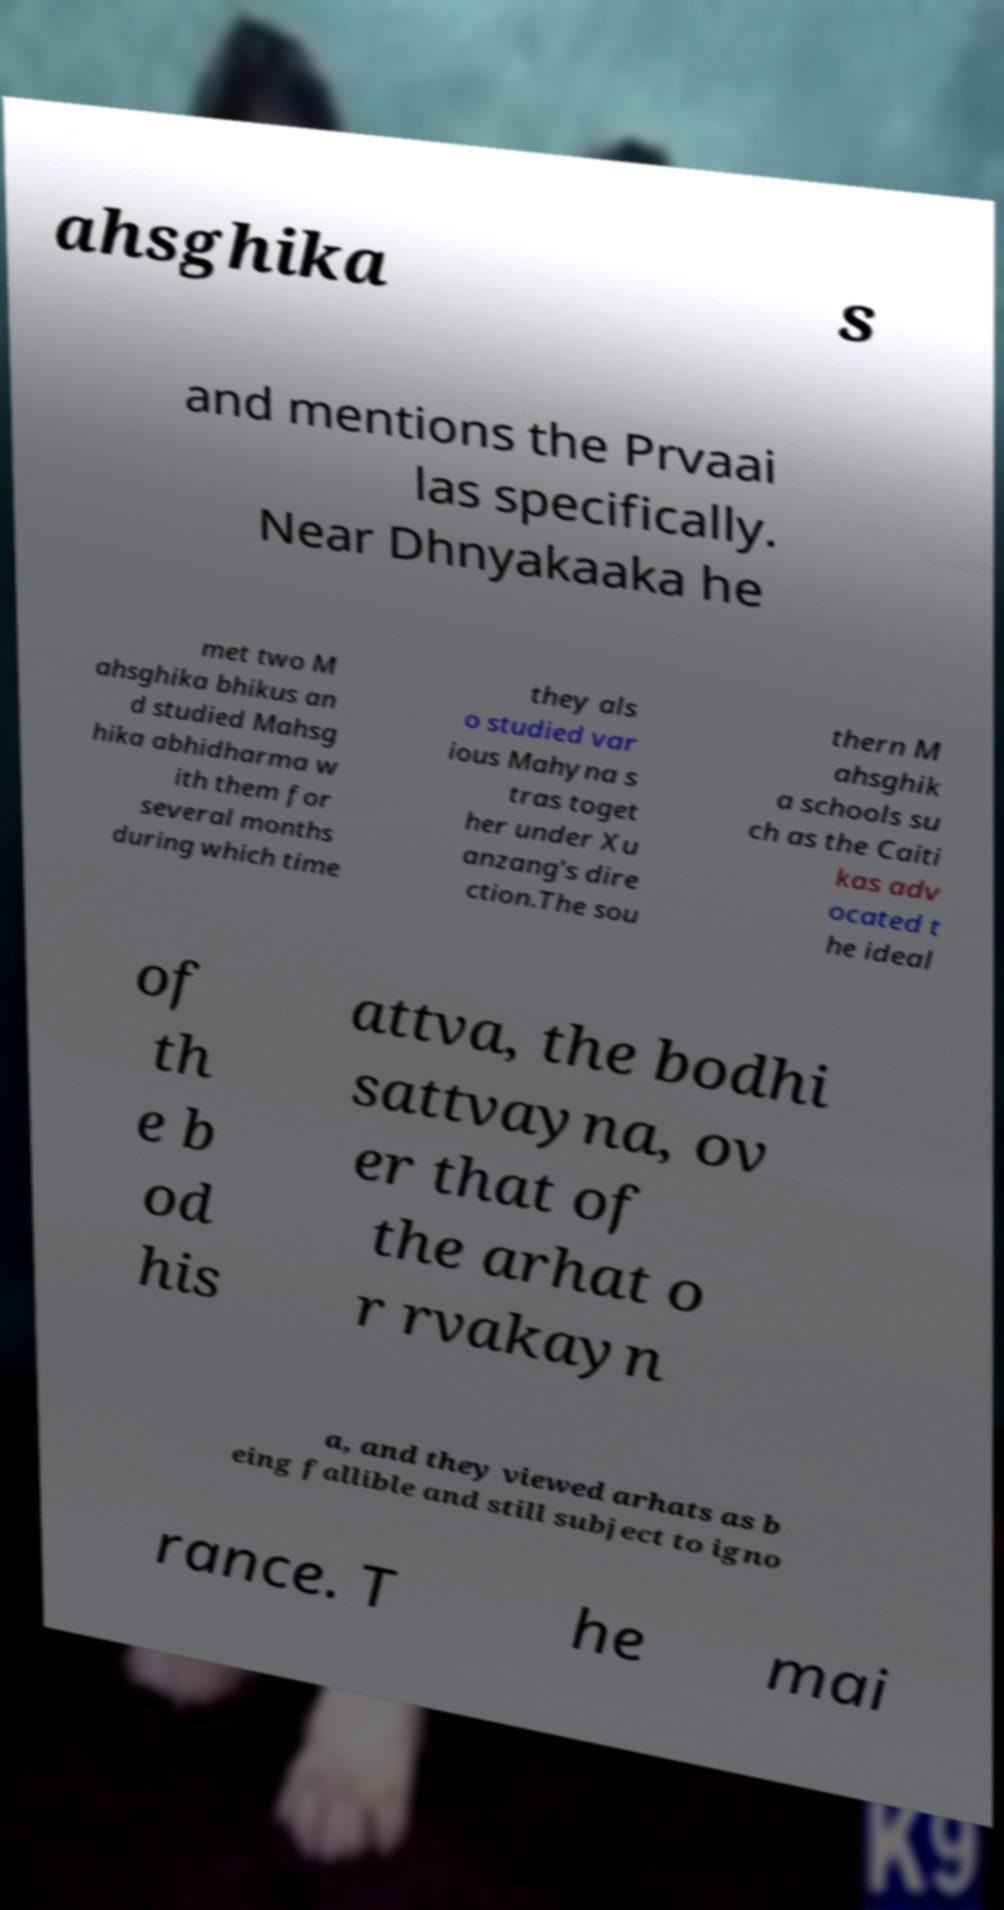Please read and relay the text visible in this image. What does it say? ahsghika s and mentions the Prvaai las specifically. Near Dhnyakaaka he met two M ahsghika bhikus an d studied Mahsg hika abhidharma w ith them for several months during which time they als o studied var ious Mahyna s tras toget her under Xu anzang's dire ction.The sou thern M ahsghik a schools su ch as the Caiti kas adv ocated t he ideal of th e b od his attva, the bodhi sattvayna, ov er that of the arhat o r rvakayn a, and they viewed arhats as b eing fallible and still subject to igno rance. T he mai 